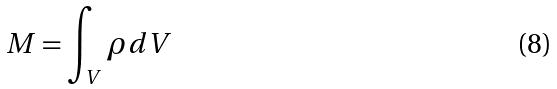Convert formula to latex. <formula><loc_0><loc_0><loc_500><loc_500>M = \int _ { V } \rho d V</formula> 